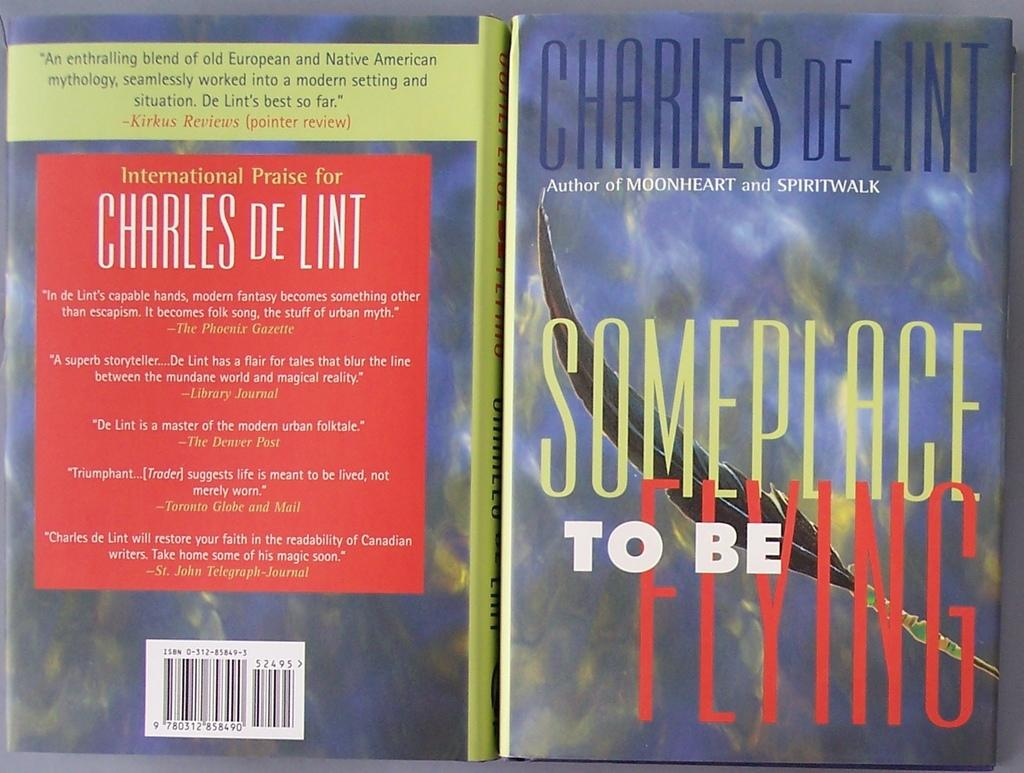<image>
Write a terse but informative summary of the picture. A cover for the book "Someplace to be Flying." 